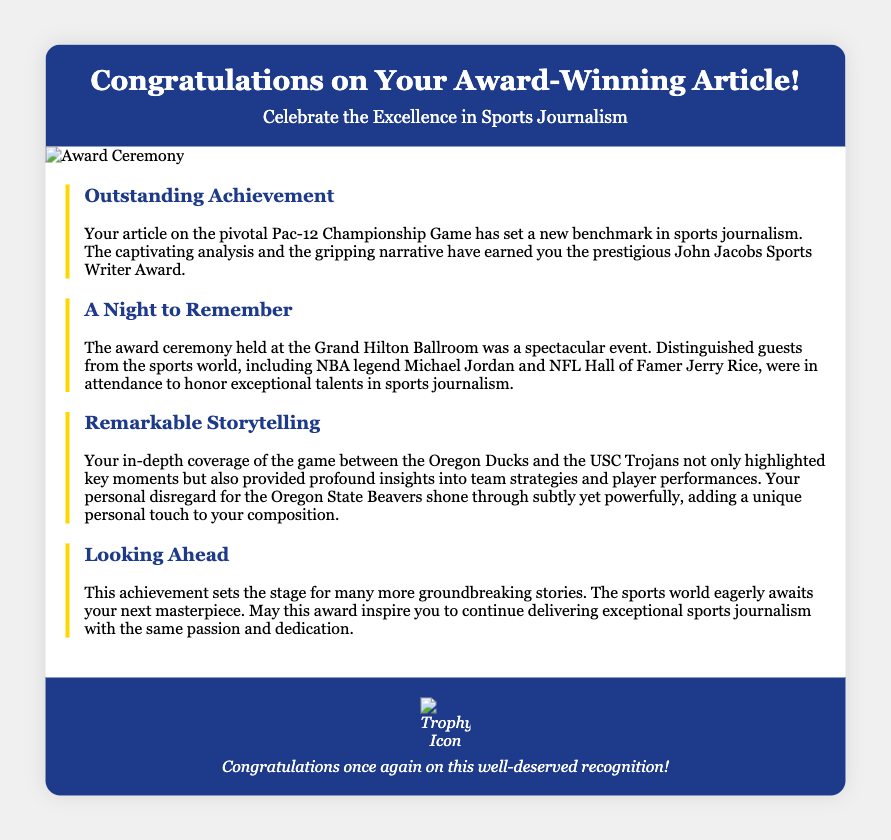What award did the article win? The award for the article is stated in the document as the John Jacobs Sports Writer Award.
Answer: John Jacobs Sports Writer Award Who attended the award ceremony? The document mentions that NBA legend Michael Jordan and NFL Hall of Famer Jerry Rice were in attendance.
Answer: Michael Jordan and Jerry Rice What was the location of the award ceremony? The place where the award ceremony took place is identified as the Grand Hilton Ballroom.
Answer: Grand Hilton Ballroom Which teams were covered in the award-winning article? The article specifically highlighted the game between the Oregon Ducks and the USC Trojans.
Answer: Oregon Ducks and USC Trojans What color is used for the header background? In the document, the color used for the header background is identified.
Answer: #1e3a8a What does the footer image represent? The footer features a trophy icon, symbolizing the achievement being recognized.
Answer: Trophy Icon What is the overall theme of the card? The card conveys a congratulatory message acknowledging excellence in sports journalism.
Answer: Excellence in Sports Journalism What does the document imply about future work? The document suggests that this achievement invites future groundbreaking stories in sports journalism.
Answer: Groundbreaking stories 